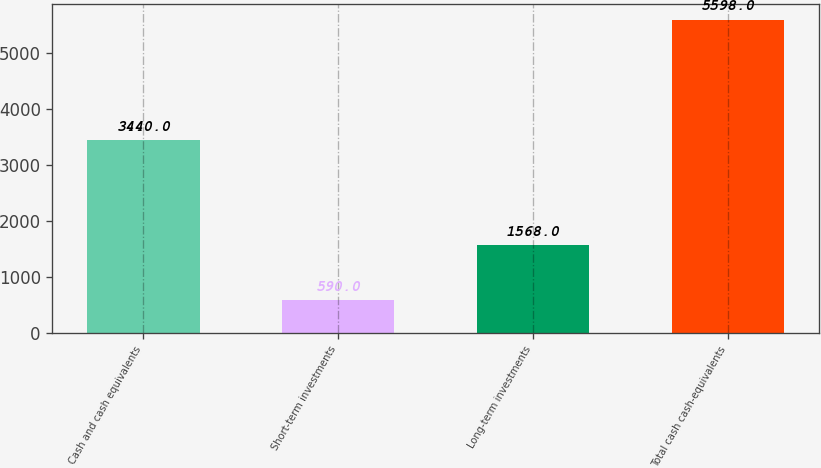Convert chart. <chart><loc_0><loc_0><loc_500><loc_500><bar_chart><fcel>Cash and cash equivalents<fcel>Short-term investments<fcel>Long-term investments<fcel>Total cash cash-equivalents<nl><fcel>3440<fcel>590<fcel>1568<fcel>5598<nl></chart> 